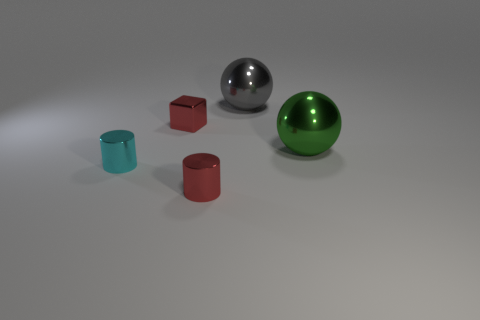Subtract all red cylinders. How many cylinders are left? 1 Add 2 small cylinders. How many objects exist? 7 Subtract all cylinders. How many objects are left? 3 Subtract 1 spheres. How many spheres are left? 1 Add 3 green objects. How many green objects exist? 4 Subtract 0 blue balls. How many objects are left? 5 Subtract all red cylinders. Subtract all green blocks. How many cylinders are left? 1 Subtract all green things. Subtract all gray balls. How many objects are left? 3 Add 4 tiny red blocks. How many tiny red blocks are left? 5 